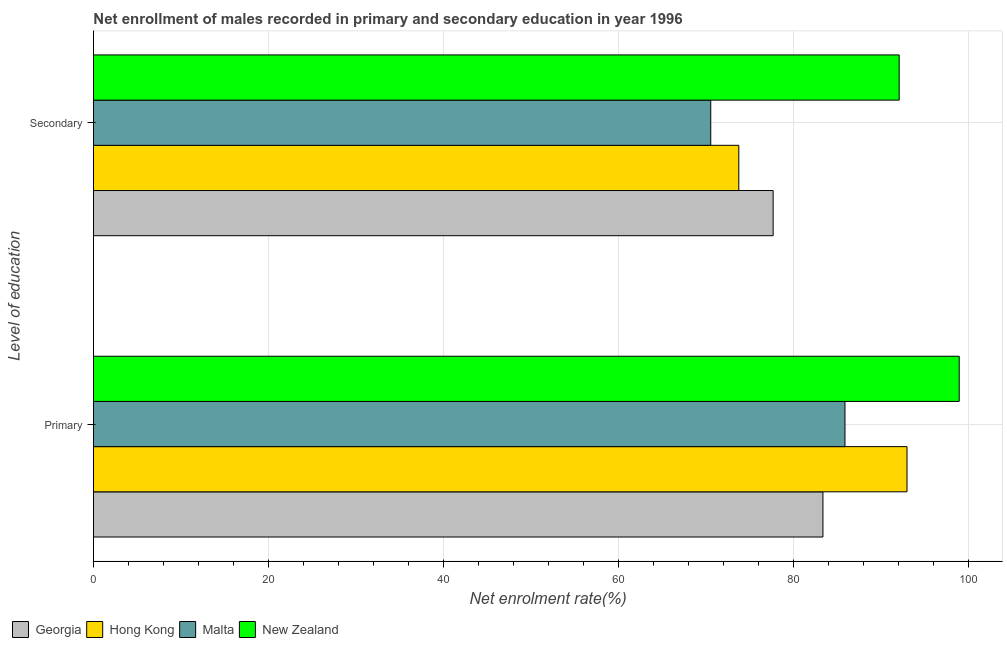How many groups of bars are there?
Ensure brevity in your answer.  2. How many bars are there on the 2nd tick from the top?
Offer a very short reply. 4. How many bars are there on the 1st tick from the bottom?
Your answer should be very brief. 4. What is the label of the 1st group of bars from the top?
Offer a very short reply. Secondary. What is the enrollment rate in secondary education in New Zealand?
Make the answer very short. 92.1. Across all countries, what is the maximum enrollment rate in primary education?
Ensure brevity in your answer.  98.96. Across all countries, what is the minimum enrollment rate in secondary education?
Offer a very short reply. 70.56. In which country was the enrollment rate in secondary education maximum?
Your response must be concise. New Zealand. In which country was the enrollment rate in primary education minimum?
Offer a terse response. Georgia. What is the total enrollment rate in secondary education in the graph?
Give a very brief answer. 314.12. What is the difference between the enrollment rate in primary education in Malta and that in Georgia?
Keep it short and to the point. 2.52. What is the difference between the enrollment rate in secondary education in Hong Kong and the enrollment rate in primary education in Georgia?
Your answer should be compact. -9.62. What is the average enrollment rate in primary education per country?
Your answer should be very brief. 90.31. What is the difference between the enrollment rate in secondary education and enrollment rate in primary education in Malta?
Ensure brevity in your answer.  -15.34. What is the ratio of the enrollment rate in primary education in Georgia to that in New Zealand?
Provide a short and direct response. 0.84. Is the enrollment rate in secondary education in Malta less than that in Georgia?
Your answer should be compact. Yes. What does the 3rd bar from the top in Secondary represents?
Ensure brevity in your answer.  Hong Kong. What does the 1st bar from the bottom in Secondary represents?
Your answer should be very brief. Georgia. How many bars are there?
Make the answer very short. 8. Are all the bars in the graph horizontal?
Your answer should be very brief. Yes. Are the values on the major ticks of X-axis written in scientific E-notation?
Provide a succinct answer. No. Does the graph contain any zero values?
Keep it short and to the point. No. Where does the legend appear in the graph?
Your answer should be very brief. Bottom left. What is the title of the graph?
Offer a terse response. Net enrollment of males recorded in primary and secondary education in year 1996. Does "Turkey" appear as one of the legend labels in the graph?
Your answer should be very brief. No. What is the label or title of the X-axis?
Keep it short and to the point. Net enrolment rate(%). What is the label or title of the Y-axis?
Keep it short and to the point. Level of education. What is the Net enrolment rate(%) in Georgia in Primary?
Provide a succinct answer. 83.38. What is the Net enrolment rate(%) of Hong Kong in Primary?
Offer a very short reply. 92.99. What is the Net enrolment rate(%) of Malta in Primary?
Your answer should be compact. 85.91. What is the Net enrolment rate(%) in New Zealand in Primary?
Your response must be concise. 98.96. What is the Net enrolment rate(%) in Georgia in Secondary?
Your response must be concise. 77.69. What is the Net enrolment rate(%) of Hong Kong in Secondary?
Provide a succinct answer. 73.77. What is the Net enrolment rate(%) in Malta in Secondary?
Your answer should be compact. 70.56. What is the Net enrolment rate(%) in New Zealand in Secondary?
Provide a short and direct response. 92.1. Across all Level of education, what is the maximum Net enrolment rate(%) in Georgia?
Make the answer very short. 83.38. Across all Level of education, what is the maximum Net enrolment rate(%) of Hong Kong?
Your response must be concise. 92.99. Across all Level of education, what is the maximum Net enrolment rate(%) in Malta?
Make the answer very short. 85.91. Across all Level of education, what is the maximum Net enrolment rate(%) in New Zealand?
Offer a very short reply. 98.96. Across all Level of education, what is the minimum Net enrolment rate(%) in Georgia?
Your answer should be compact. 77.69. Across all Level of education, what is the minimum Net enrolment rate(%) in Hong Kong?
Provide a succinct answer. 73.77. Across all Level of education, what is the minimum Net enrolment rate(%) of Malta?
Offer a very short reply. 70.56. Across all Level of education, what is the minimum Net enrolment rate(%) of New Zealand?
Offer a very short reply. 92.1. What is the total Net enrolment rate(%) of Georgia in the graph?
Keep it short and to the point. 161.08. What is the total Net enrolment rate(%) in Hong Kong in the graph?
Your response must be concise. 166.76. What is the total Net enrolment rate(%) of Malta in the graph?
Your answer should be compact. 156.47. What is the total Net enrolment rate(%) in New Zealand in the graph?
Your answer should be compact. 191.06. What is the difference between the Net enrolment rate(%) in Georgia in Primary and that in Secondary?
Provide a succinct answer. 5.69. What is the difference between the Net enrolment rate(%) in Hong Kong in Primary and that in Secondary?
Provide a succinct answer. 19.23. What is the difference between the Net enrolment rate(%) in Malta in Primary and that in Secondary?
Make the answer very short. 15.35. What is the difference between the Net enrolment rate(%) of New Zealand in Primary and that in Secondary?
Ensure brevity in your answer.  6.86. What is the difference between the Net enrolment rate(%) of Georgia in Primary and the Net enrolment rate(%) of Hong Kong in Secondary?
Provide a succinct answer. 9.62. What is the difference between the Net enrolment rate(%) of Georgia in Primary and the Net enrolment rate(%) of Malta in Secondary?
Your response must be concise. 12.82. What is the difference between the Net enrolment rate(%) in Georgia in Primary and the Net enrolment rate(%) in New Zealand in Secondary?
Provide a short and direct response. -8.72. What is the difference between the Net enrolment rate(%) of Hong Kong in Primary and the Net enrolment rate(%) of Malta in Secondary?
Give a very brief answer. 22.43. What is the difference between the Net enrolment rate(%) of Hong Kong in Primary and the Net enrolment rate(%) of New Zealand in Secondary?
Provide a succinct answer. 0.89. What is the difference between the Net enrolment rate(%) in Malta in Primary and the Net enrolment rate(%) in New Zealand in Secondary?
Your answer should be very brief. -6.2. What is the average Net enrolment rate(%) of Georgia per Level of education?
Offer a very short reply. 80.54. What is the average Net enrolment rate(%) in Hong Kong per Level of education?
Give a very brief answer. 83.38. What is the average Net enrolment rate(%) of Malta per Level of education?
Your answer should be compact. 78.23. What is the average Net enrolment rate(%) in New Zealand per Level of education?
Offer a terse response. 95.53. What is the difference between the Net enrolment rate(%) in Georgia and Net enrolment rate(%) in Hong Kong in Primary?
Offer a terse response. -9.61. What is the difference between the Net enrolment rate(%) of Georgia and Net enrolment rate(%) of Malta in Primary?
Keep it short and to the point. -2.52. What is the difference between the Net enrolment rate(%) in Georgia and Net enrolment rate(%) in New Zealand in Primary?
Your response must be concise. -15.58. What is the difference between the Net enrolment rate(%) of Hong Kong and Net enrolment rate(%) of Malta in Primary?
Provide a short and direct response. 7.09. What is the difference between the Net enrolment rate(%) in Hong Kong and Net enrolment rate(%) in New Zealand in Primary?
Make the answer very short. -5.97. What is the difference between the Net enrolment rate(%) of Malta and Net enrolment rate(%) of New Zealand in Primary?
Give a very brief answer. -13.06. What is the difference between the Net enrolment rate(%) in Georgia and Net enrolment rate(%) in Hong Kong in Secondary?
Your response must be concise. 3.93. What is the difference between the Net enrolment rate(%) of Georgia and Net enrolment rate(%) of Malta in Secondary?
Provide a short and direct response. 7.13. What is the difference between the Net enrolment rate(%) in Georgia and Net enrolment rate(%) in New Zealand in Secondary?
Give a very brief answer. -14.41. What is the difference between the Net enrolment rate(%) in Hong Kong and Net enrolment rate(%) in Malta in Secondary?
Make the answer very short. 3.21. What is the difference between the Net enrolment rate(%) in Hong Kong and Net enrolment rate(%) in New Zealand in Secondary?
Ensure brevity in your answer.  -18.33. What is the difference between the Net enrolment rate(%) in Malta and Net enrolment rate(%) in New Zealand in Secondary?
Make the answer very short. -21.54. What is the ratio of the Net enrolment rate(%) in Georgia in Primary to that in Secondary?
Make the answer very short. 1.07. What is the ratio of the Net enrolment rate(%) of Hong Kong in Primary to that in Secondary?
Give a very brief answer. 1.26. What is the ratio of the Net enrolment rate(%) of Malta in Primary to that in Secondary?
Your response must be concise. 1.22. What is the ratio of the Net enrolment rate(%) in New Zealand in Primary to that in Secondary?
Your response must be concise. 1.07. What is the difference between the highest and the second highest Net enrolment rate(%) of Georgia?
Ensure brevity in your answer.  5.69. What is the difference between the highest and the second highest Net enrolment rate(%) in Hong Kong?
Make the answer very short. 19.23. What is the difference between the highest and the second highest Net enrolment rate(%) in Malta?
Offer a very short reply. 15.35. What is the difference between the highest and the second highest Net enrolment rate(%) of New Zealand?
Make the answer very short. 6.86. What is the difference between the highest and the lowest Net enrolment rate(%) of Georgia?
Keep it short and to the point. 5.69. What is the difference between the highest and the lowest Net enrolment rate(%) of Hong Kong?
Keep it short and to the point. 19.23. What is the difference between the highest and the lowest Net enrolment rate(%) of Malta?
Your response must be concise. 15.35. What is the difference between the highest and the lowest Net enrolment rate(%) of New Zealand?
Your answer should be very brief. 6.86. 